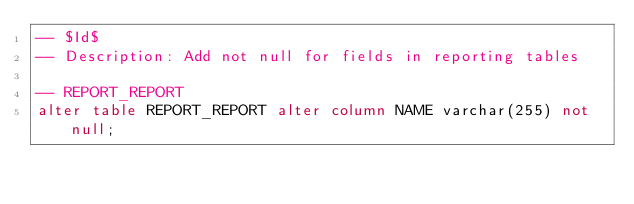<code> <loc_0><loc_0><loc_500><loc_500><_SQL_>-- $Id$
-- Description: Add not null for fields in reporting tables

-- REPORT_REPORT
alter table REPORT_REPORT alter column NAME varchar(255) not null;
</code> 